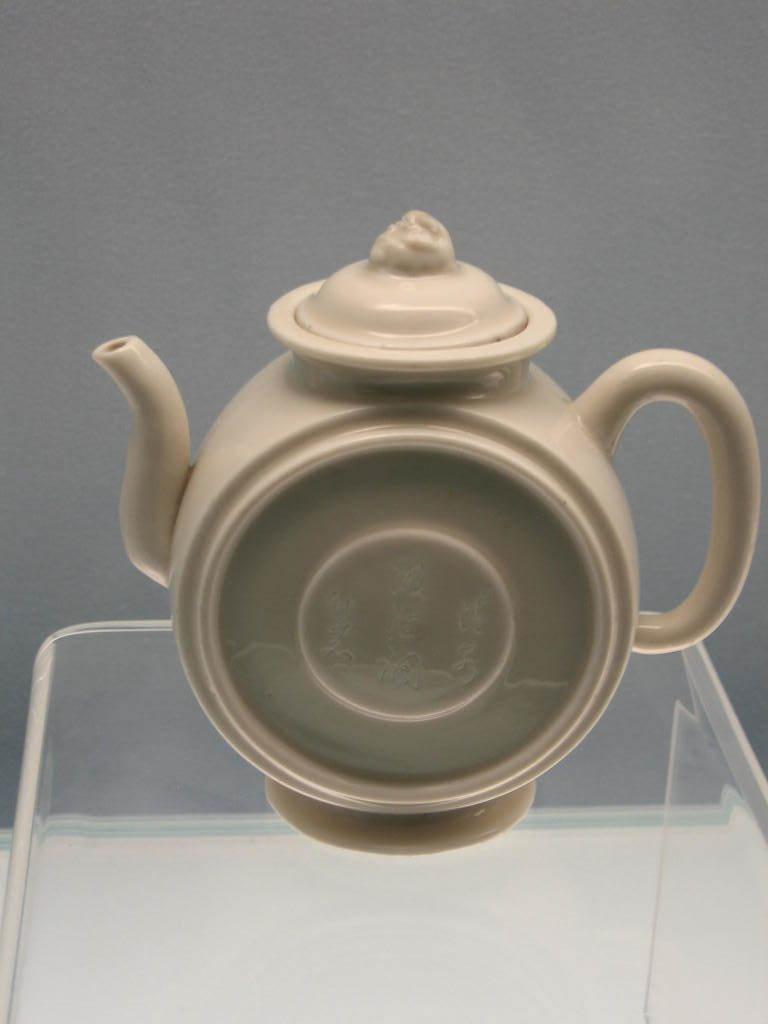What object is the main subject of the image? There is a teapot in the image. Where is the teapot located? The teapot is placed on a table. What material is the table made of? The table is made of glass. What can be seen in the background of the image? There is a wall in the background of the image. What type of drink is being served in the camp in the image? There is no camp or drink present in the image; it features a teapot on a glass table with a wall in the background. 